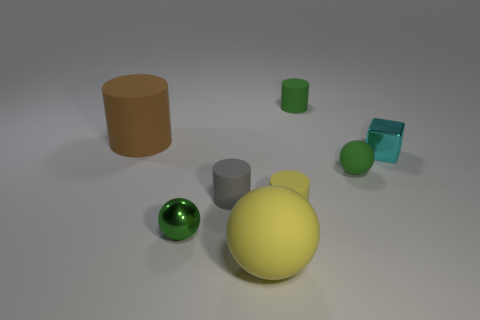What time of day does this setting suggest? The lighting in the image does not clearly indicate a time of day, as it appears to be a neutral lit studio setting with soft shadows, suggesting an indoor photo shoot rather than natural light. 